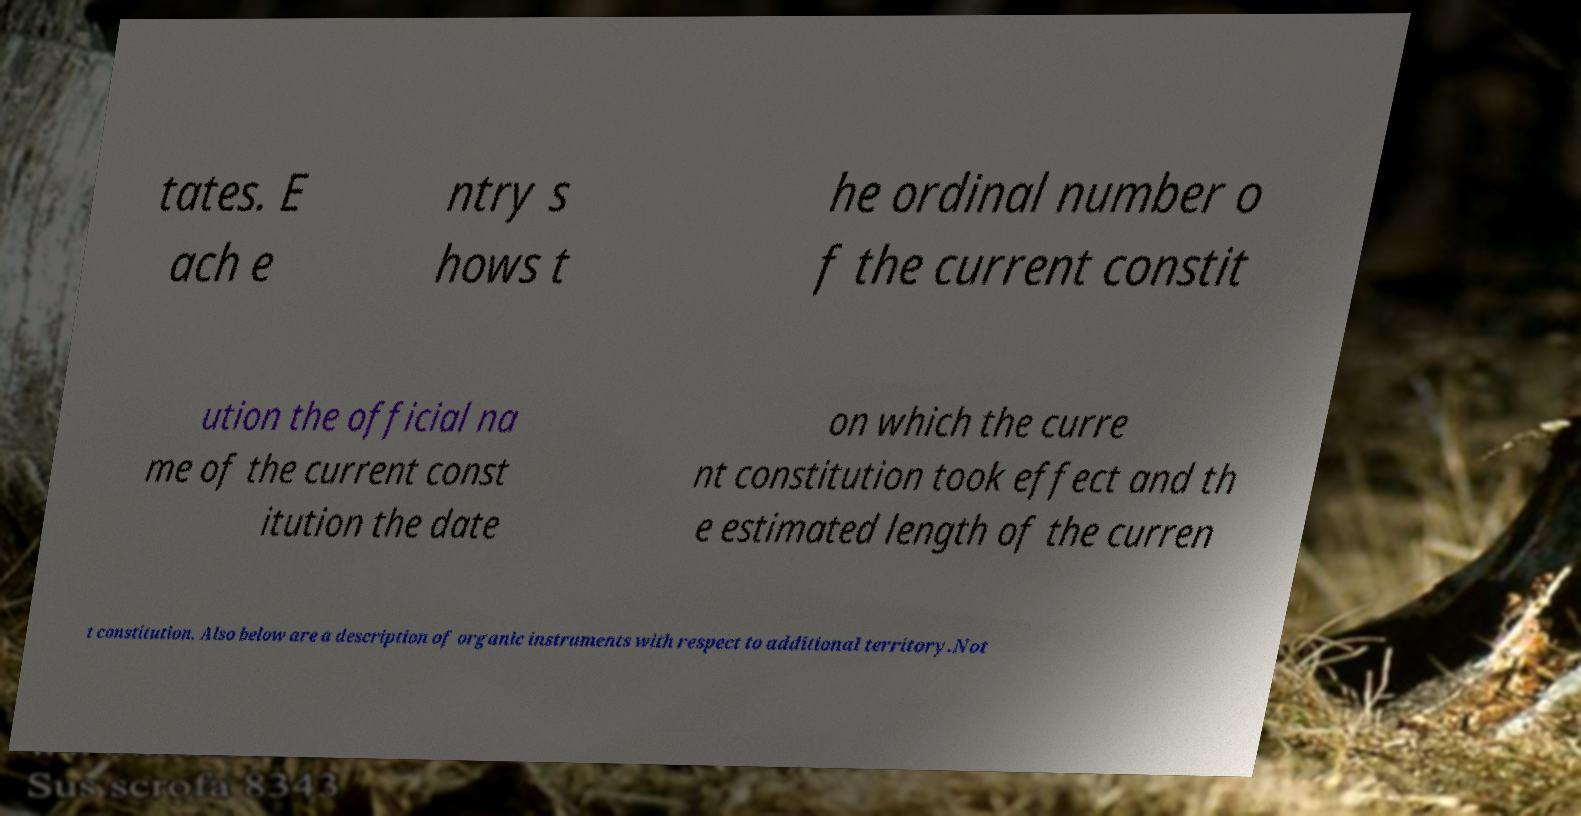Can you read and provide the text displayed in the image?This photo seems to have some interesting text. Can you extract and type it out for me? tates. E ach e ntry s hows t he ordinal number o f the current constit ution the official na me of the current const itution the date on which the curre nt constitution took effect and th e estimated length of the curren t constitution. Also below are a description of organic instruments with respect to additional territory.Not 